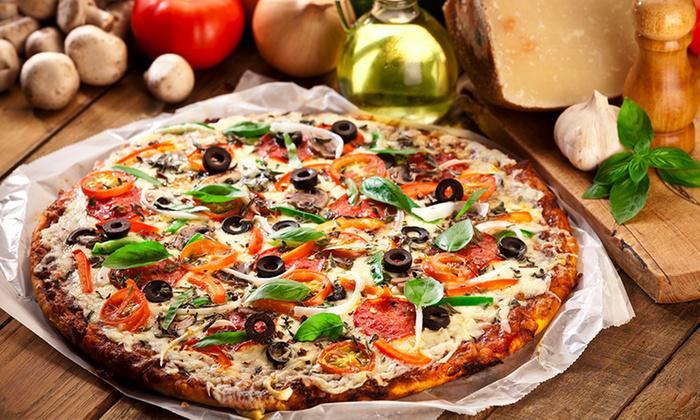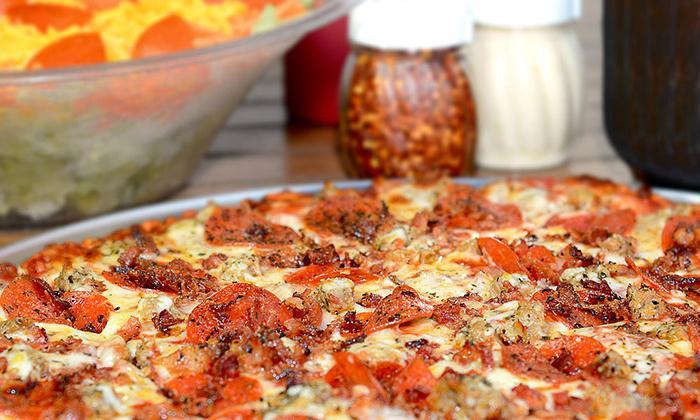The first image is the image on the left, the second image is the image on the right. For the images displayed, is the sentence "One slice of pizza is being separated from the rest." factually correct? Answer yes or no. No. The first image is the image on the left, the second image is the image on the right. Assess this claim about the two images: "A whole pizza is on a pizza box in the right image.". Correct or not? Answer yes or no. No. 